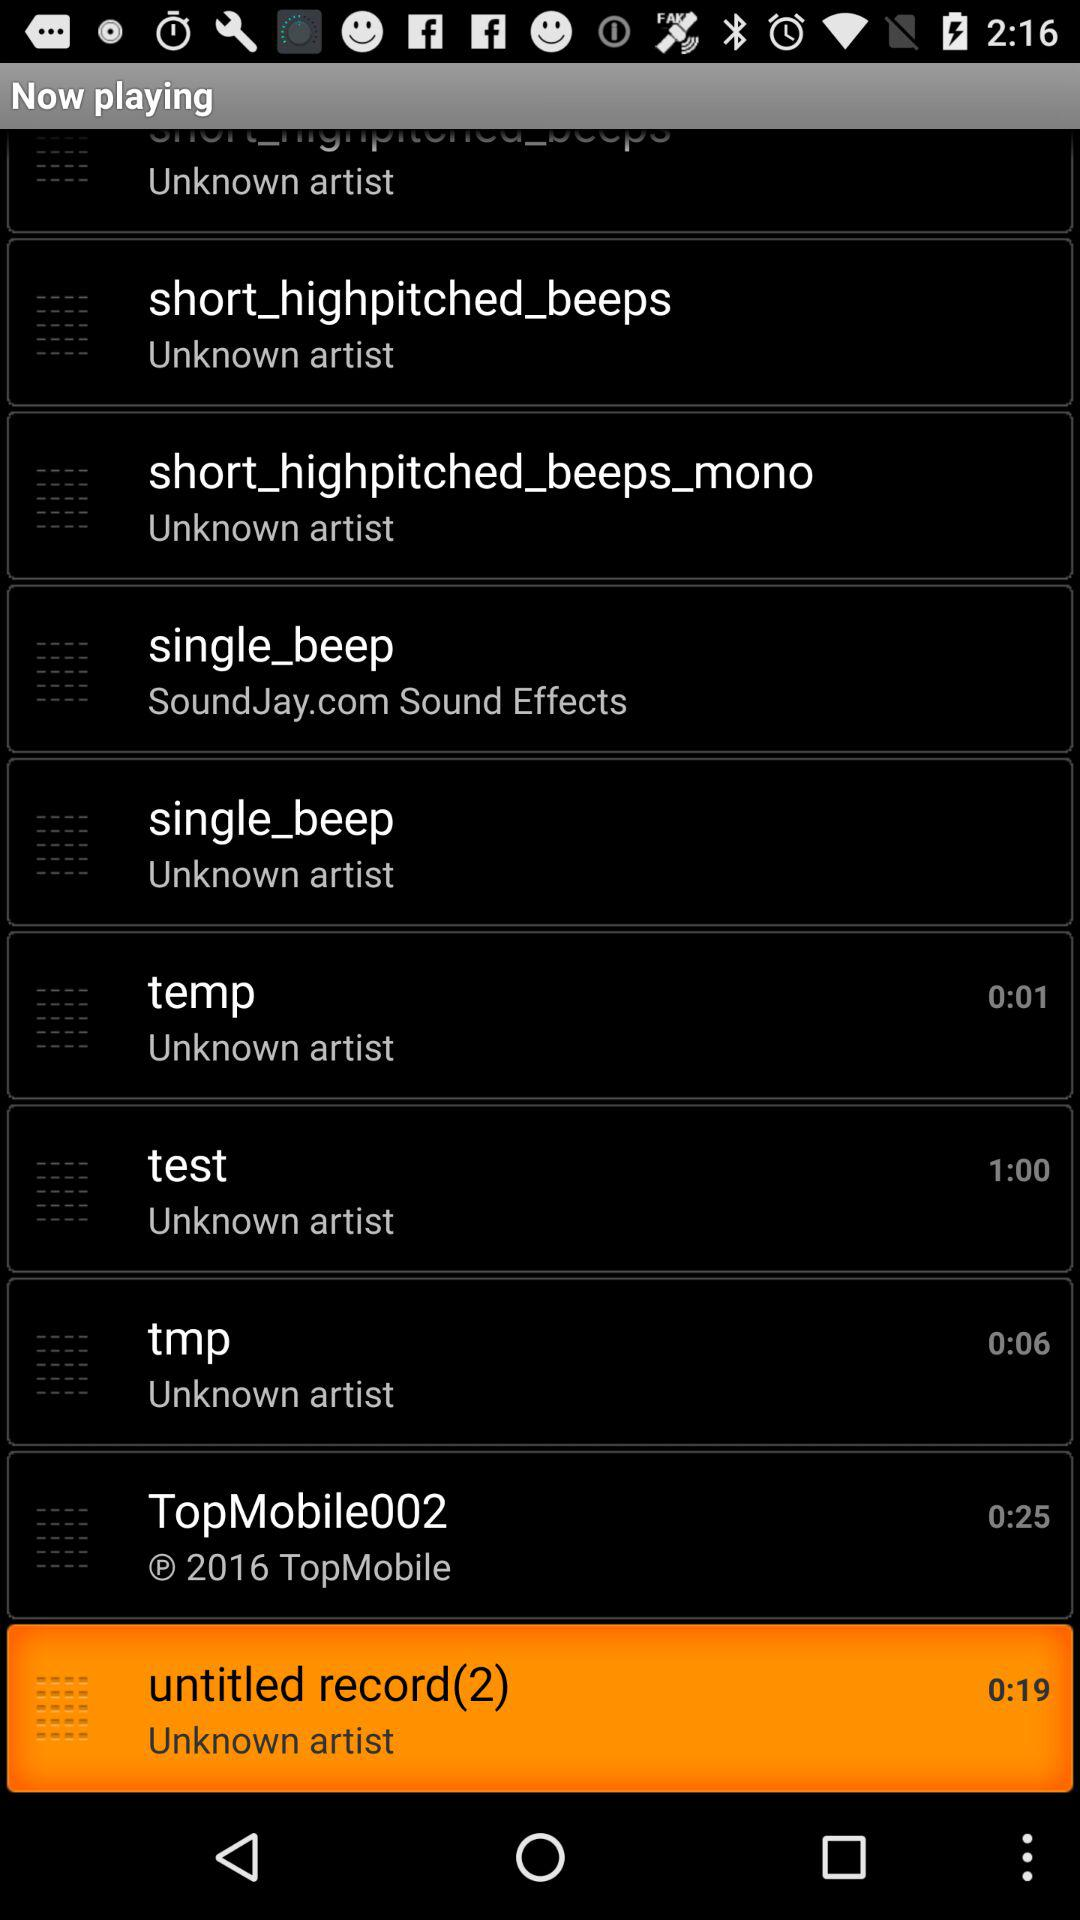Which audio is playing? The playing audio is "untitled record(2)". 